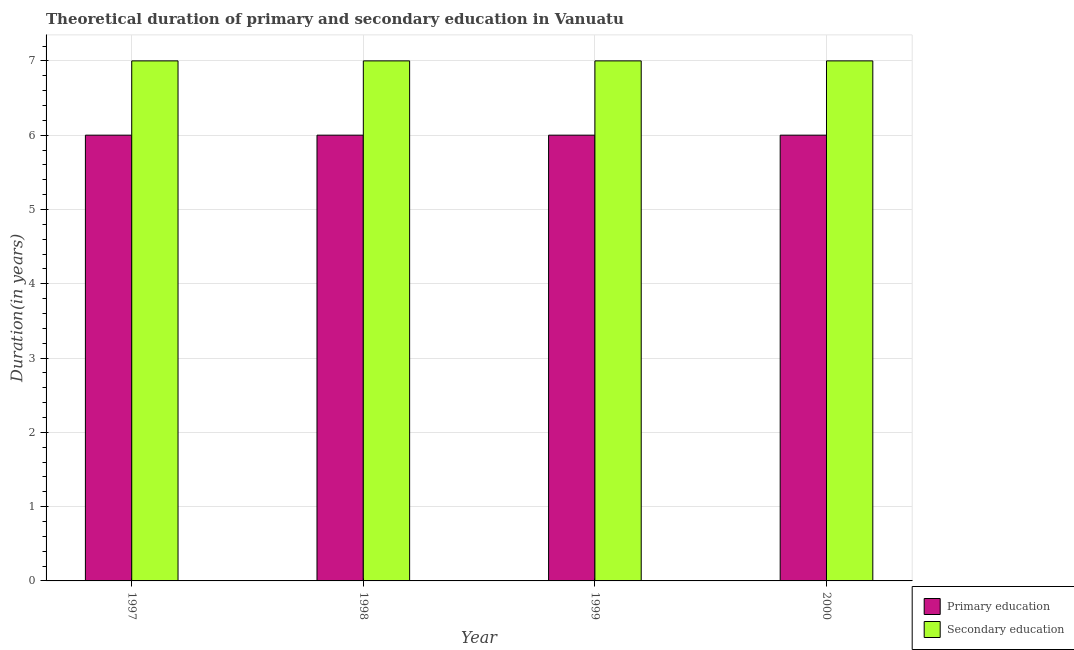How many different coloured bars are there?
Provide a succinct answer. 2. How many bars are there on the 4th tick from the left?
Provide a short and direct response. 2. How many bars are there on the 2nd tick from the right?
Make the answer very short. 2. In how many cases, is the number of bars for a given year not equal to the number of legend labels?
Provide a short and direct response. 0. What is the duration of primary education in 2000?
Make the answer very short. 6. Across all years, what is the maximum duration of secondary education?
Keep it short and to the point. 7. Across all years, what is the minimum duration of secondary education?
Ensure brevity in your answer.  7. What is the total duration of primary education in the graph?
Provide a short and direct response. 24. What is the difference between the duration of secondary education in 1998 and that in 2000?
Offer a terse response. 0. In how many years, is the duration of secondary education greater than 4.6 years?
Ensure brevity in your answer.  4. What is the ratio of the duration of secondary education in 1998 to that in 1999?
Provide a short and direct response. 1. Is the duration of primary education in 1997 less than that in 2000?
Give a very brief answer. No. What is the difference between the highest and the lowest duration of primary education?
Give a very brief answer. 0. What does the 2nd bar from the left in 2000 represents?
Provide a short and direct response. Secondary education. What does the 1st bar from the right in 1999 represents?
Give a very brief answer. Secondary education. What is the difference between two consecutive major ticks on the Y-axis?
Keep it short and to the point. 1. How are the legend labels stacked?
Provide a short and direct response. Vertical. What is the title of the graph?
Your answer should be compact. Theoretical duration of primary and secondary education in Vanuatu. What is the label or title of the X-axis?
Your answer should be very brief. Year. What is the label or title of the Y-axis?
Provide a succinct answer. Duration(in years). What is the Duration(in years) of Primary education in 1999?
Your answer should be very brief. 6. What is the Duration(in years) in Secondary education in 1999?
Offer a terse response. 7. What is the Duration(in years) in Primary education in 2000?
Give a very brief answer. 6. Across all years, what is the maximum Duration(in years) in Secondary education?
Offer a very short reply. 7. What is the total Duration(in years) of Primary education in the graph?
Make the answer very short. 24. What is the total Duration(in years) of Secondary education in the graph?
Keep it short and to the point. 28. What is the difference between the Duration(in years) of Secondary education in 1997 and that in 1999?
Offer a terse response. 0. What is the difference between the Duration(in years) in Primary education in 1998 and that in 1999?
Your response must be concise. 0. What is the difference between the Duration(in years) of Primary education in 1997 and the Duration(in years) of Secondary education in 1998?
Give a very brief answer. -1. What is the difference between the Duration(in years) of Primary education in 1997 and the Duration(in years) of Secondary education in 2000?
Offer a very short reply. -1. In the year 1997, what is the difference between the Duration(in years) in Primary education and Duration(in years) in Secondary education?
Your answer should be compact. -1. In the year 1998, what is the difference between the Duration(in years) in Primary education and Duration(in years) in Secondary education?
Make the answer very short. -1. In the year 1999, what is the difference between the Duration(in years) in Primary education and Duration(in years) in Secondary education?
Make the answer very short. -1. What is the ratio of the Duration(in years) in Secondary education in 1997 to that in 1998?
Make the answer very short. 1. What is the ratio of the Duration(in years) of Primary education in 1997 to that in 1999?
Keep it short and to the point. 1. What is the ratio of the Duration(in years) of Secondary education in 1997 to that in 1999?
Your response must be concise. 1. What is the ratio of the Duration(in years) of Primary education in 1997 to that in 2000?
Your answer should be very brief. 1. What is the ratio of the Duration(in years) in Primary education in 1998 to that in 1999?
Offer a terse response. 1. What is the ratio of the Duration(in years) in Secondary education in 1998 to that in 1999?
Your answer should be compact. 1. What is the ratio of the Duration(in years) of Primary education in 1999 to that in 2000?
Offer a very short reply. 1. What is the ratio of the Duration(in years) of Secondary education in 1999 to that in 2000?
Keep it short and to the point. 1. What is the difference between the highest and the lowest Duration(in years) of Secondary education?
Your answer should be compact. 0. 